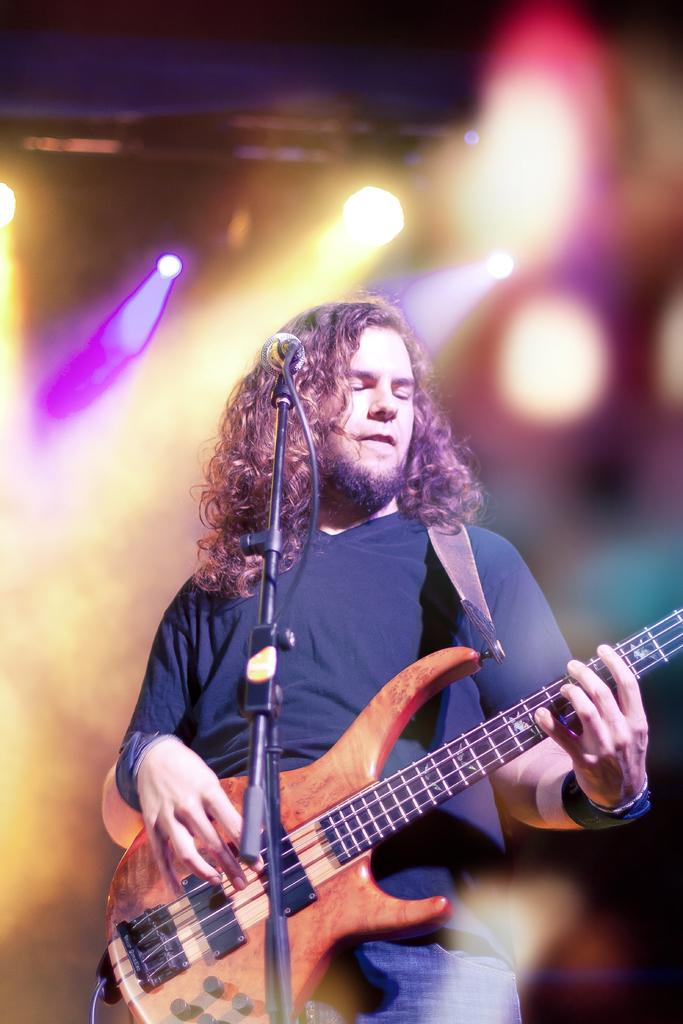What is the person in the image doing? The person is playing a brown guitar. What is the person wearing? The person is wearing a black t-shirt and jeans. What object is in front of the person? There is a microphone in front of the person. What can be seen behind the person? There are lights visible behind the person. What type of linen is draped over the frame of the guitar in the image? There is no linen draped over the frame of the guitar in the image. Can you describe the sink that is visible in the image? There is no sink present in the image. 